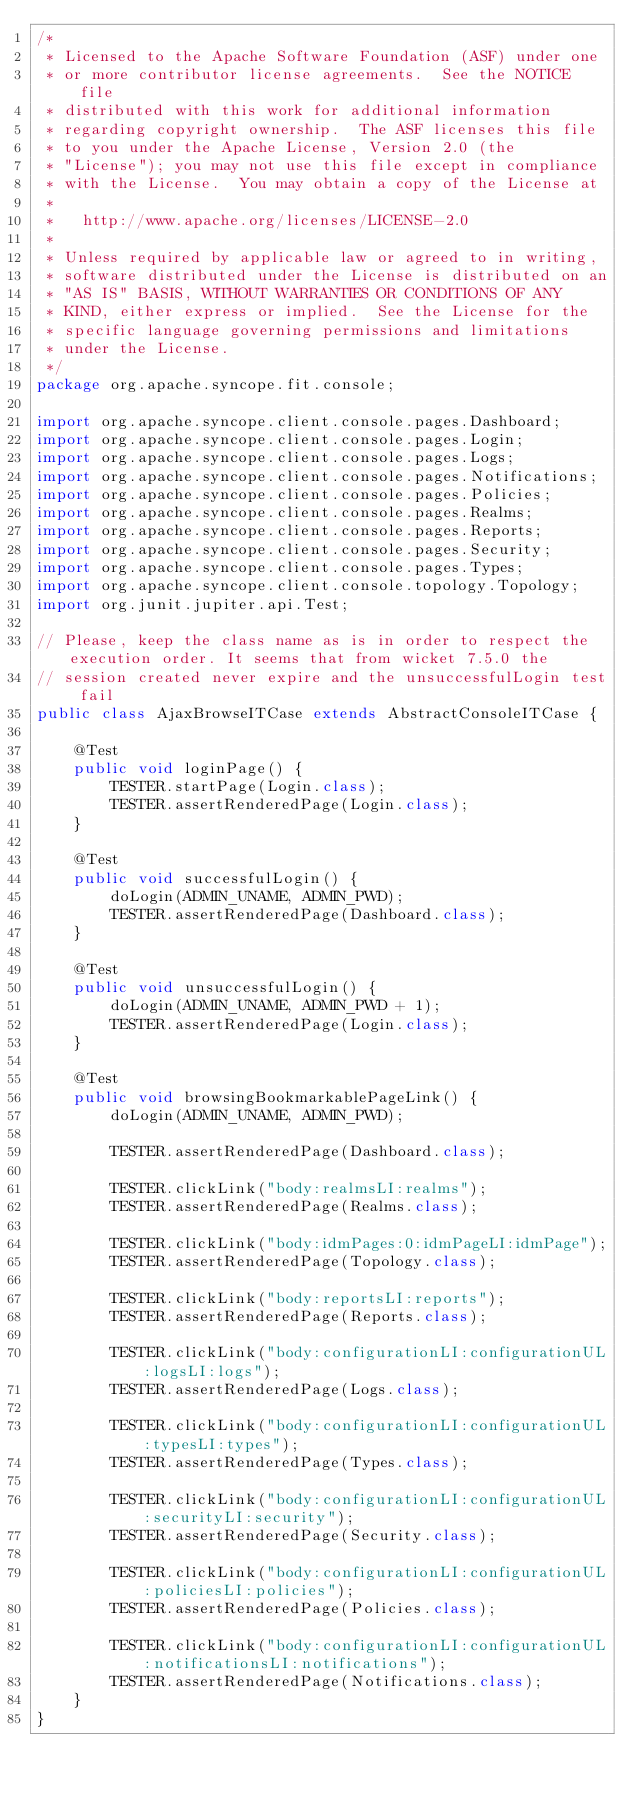Convert code to text. <code><loc_0><loc_0><loc_500><loc_500><_Java_>/*
 * Licensed to the Apache Software Foundation (ASF) under one
 * or more contributor license agreements.  See the NOTICE file
 * distributed with this work for additional information
 * regarding copyright ownership.  The ASF licenses this file
 * to you under the Apache License, Version 2.0 (the
 * "License"); you may not use this file except in compliance
 * with the License.  You may obtain a copy of the License at
 *
 *   http://www.apache.org/licenses/LICENSE-2.0
 *
 * Unless required by applicable law or agreed to in writing,
 * software distributed under the License is distributed on an
 * "AS IS" BASIS, WITHOUT WARRANTIES OR CONDITIONS OF ANY
 * KIND, either express or implied.  See the License for the
 * specific language governing permissions and limitations
 * under the License.
 */
package org.apache.syncope.fit.console;

import org.apache.syncope.client.console.pages.Dashboard;
import org.apache.syncope.client.console.pages.Login;
import org.apache.syncope.client.console.pages.Logs;
import org.apache.syncope.client.console.pages.Notifications;
import org.apache.syncope.client.console.pages.Policies;
import org.apache.syncope.client.console.pages.Realms;
import org.apache.syncope.client.console.pages.Reports;
import org.apache.syncope.client.console.pages.Security;
import org.apache.syncope.client.console.pages.Types;
import org.apache.syncope.client.console.topology.Topology;
import org.junit.jupiter.api.Test;

// Please, keep the class name as is in order to respect the execution order. It seems that from wicket 7.5.0 the 
// session created never expire and the unsuccessfulLogin test fail
public class AjaxBrowseITCase extends AbstractConsoleITCase {

    @Test
    public void loginPage() {
        TESTER.startPage(Login.class);
        TESTER.assertRenderedPage(Login.class);
    }

    @Test
    public void successfulLogin() {
        doLogin(ADMIN_UNAME, ADMIN_PWD);
        TESTER.assertRenderedPage(Dashboard.class);
    }

    @Test
    public void unsuccessfulLogin() {
        doLogin(ADMIN_UNAME, ADMIN_PWD + 1);
        TESTER.assertRenderedPage(Login.class);
    }

    @Test
    public void browsingBookmarkablePageLink() {
        doLogin(ADMIN_UNAME, ADMIN_PWD);

        TESTER.assertRenderedPage(Dashboard.class);

        TESTER.clickLink("body:realmsLI:realms");
        TESTER.assertRenderedPage(Realms.class);

        TESTER.clickLink("body:idmPages:0:idmPageLI:idmPage");
        TESTER.assertRenderedPage(Topology.class);

        TESTER.clickLink("body:reportsLI:reports");
        TESTER.assertRenderedPage(Reports.class);

        TESTER.clickLink("body:configurationLI:configurationUL:logsLI:logs");
        TESTER.assertRenderedPage(Logs.class);

        TESTER.clickLink("body:configurationLI:configurationUL:typesLI:types");
        TESTER.assertRenderedPage(Types.class);

        TESTER.clickLink("body:configurationLI:configurationUL:securityLI:security");
        TESTER.assertRenderedPage(Security.class);

        TESTER.clickLink("body:configurationLI:configurationUL:policiesLI:policies");
        TESTER.assertRenderedPage(Policies.class);

        TESTER.clickLink("body:configurationLI:configurationUL:notificationsLI:notifications");
        TESTER.assertRenderedPage(Notifications.class);
    }
}
</code> 